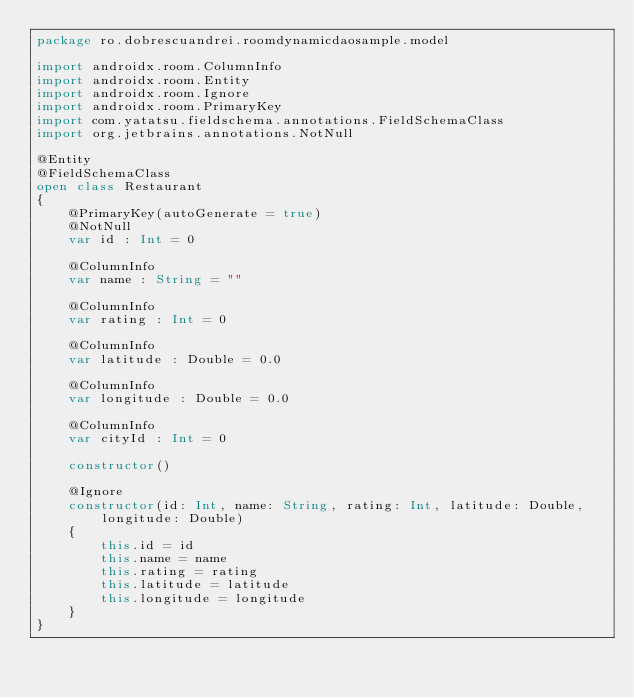Convert code to text. <code><loc_0><loc_0><loc_500><loc_500><_Kotlin_>package ro.dobrescuandrei.roomdynamicdaosample.model

import androidx.room.ColumnInfo
import androidx.room.Entity
import androidx.room.Ignore
import androidx.room.PrimaryKey
import com.yatatsu.fieldschema.annotations.FieldSchemaClass
import org.jetbrains.annotations.NotNull

@Entity
@FieldSchemaClass
open class Restaurant
{
    @PrimaryKey(autoGenerate = true)
    @NotNull
    var id : Int = 0

    @ColumnInfo
    var name : String = ""

    @ColumnInfo
    var rating : Int = 0

    @ColumnInfo
    var latitude : Double = 0.0

    @ColumnInfo
    var longitude : Double = 0.0

    @ColumnInfo
    var cityId : Int = 0

    constructor()

    @Ignore
    constructor(id: Int, name: String, rating: Int, latitude: Double, longitude: Double)
    {
        this.id = id
        this.name = name
        this.rating = rating
        this.latitude = latitude
        this.longitude = longitude
    }
}</code> 